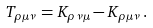Convert formula to latex. <formula><loc_0><loc_0><loc_500><loc_500>T _ { \rho \mu \nu } = K _ { \rho \nu \mu } - K _ { \rho \mu \nu } \, .</formula> 